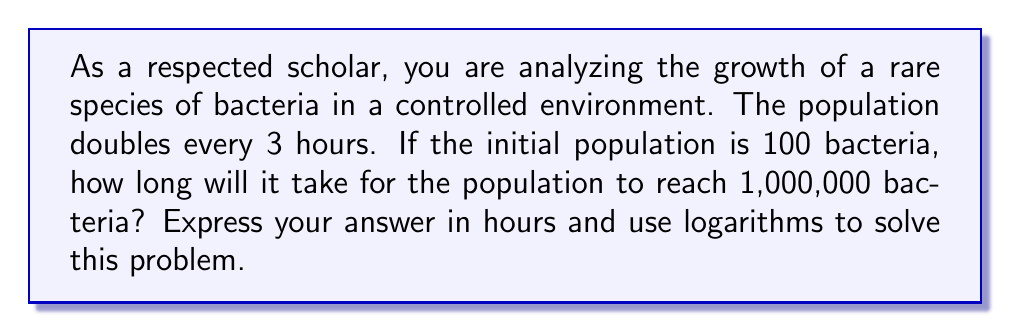Can you answer this question? Let's approach this step-by-step:

1) Let $t$ be the time in hours and $N(t)$ be the population at time $t$.

2) The initial population is 100, so $N(0) = 100$.

3) The population doubles every 3 hours, so we can express this as an exponential function:

   $N(t) = 100 \cdot 2^{\frac{t}{3}}$

4) We want to find $t$ when $N(t) = 1,000,000$. So, we can set up the equation:

   $1,000,000 = 100 \cdot 2^{\frac{t}{3}}$

5) Divide both sides by 100:

   $10,000 = 2^{\frac{t}{3}}$

6) Now, we can apply logarithms to both sides. Let's use log base 2:

   $\log_2(10,000) = \log_2(2^{\frac{t}{3}})$

7) Using the logarithm property $\log_a(a^x) = x$, we get:

   $\log_2(10,000) = \frac{t}{3}$

8) Multiply both sides by 3:

   $3 \log_2(10,000) = t$

9) We can calculate $\log_2(10,000)$ using the change of base formula:

   $\log_2(10,000) = \frac{\log(10,000)}{\log(2)} \approx 13.2877$

10) Therefore:

    $t = 3 \cdot 13.2877 \approx 39.8631$ hours
Answer: It will take approximately 39.86 hours for the bacteria population to reach 1,000,000. 